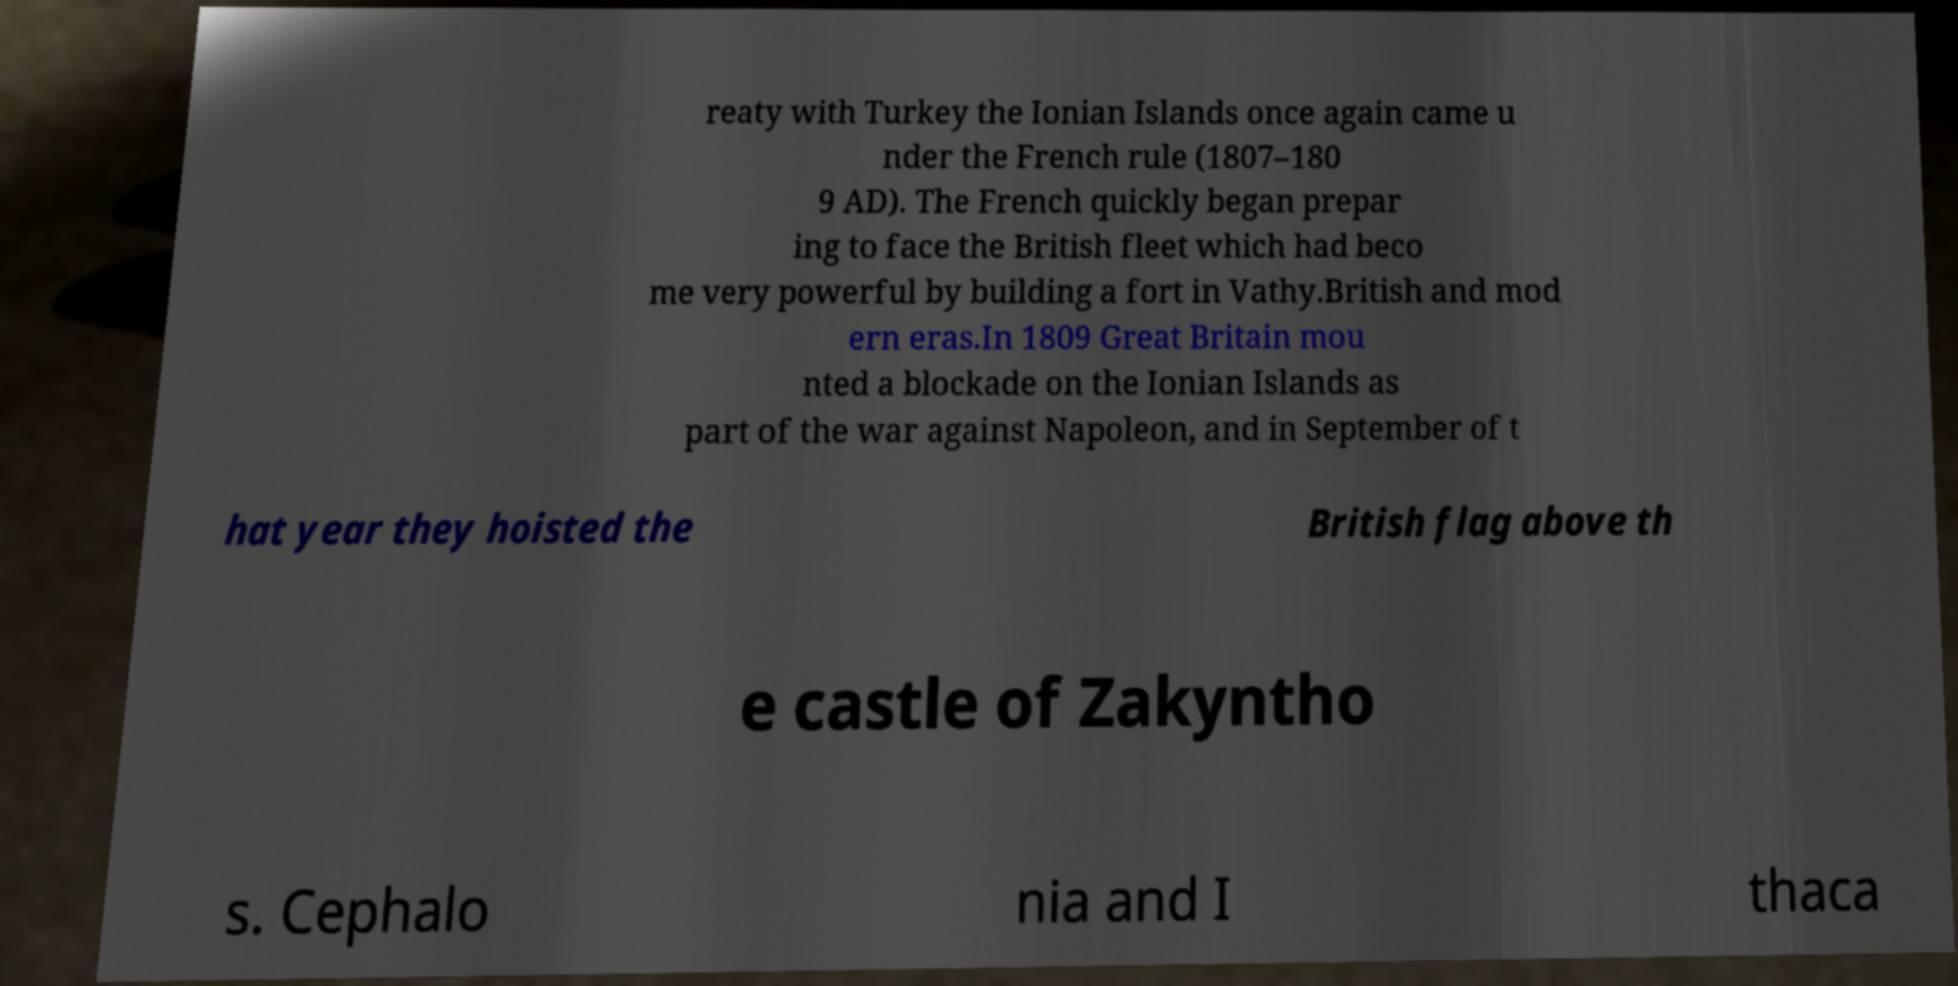Could you assist in decoding the text presented in this image and type it out clearly? reaty with Turkey the Ionian Islands once again came u nder the French rule (1807–180 9 AD). The French quickly began prepar ing to face the British fleet which had beco me very powerful by building a fort in Vathy.British and mod ern eras.In 1809 Great Britain mou nted a blockade on the Ionian Islands as part of the war against Napoleon, and in September of t hat year they hoisted the British flag above th e castle of Zakyntho s. Cephalo nia and I thaca 